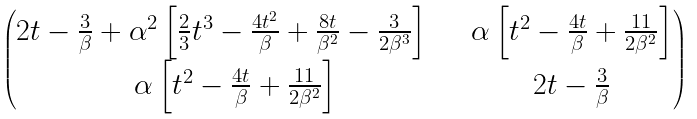Convert formula to latex. <formula><loc_0><loc_0><loc_500><loc_500>\begin{pmatrix} 2 t - \frac { 3 } { \beta } + \alpha ^ { 2 } \left [ \frac { 2 } { 3 } t ^ { 3 } - \frac { 4 t ^ { 2 } } { \beta } + \frac { 8 t } { \beta ^ { 2 } } - \frac { 3 } { 2 \beta ^ { 3 } } \right ] \quad & \alpha \left [ t ^ { 2 } - \frac { 4 t } { \beta } + \frac { 1 1 } { 2 \beta ^ { 2 } } \right ] \\ \alpha \left [ t ^ { 2 } - \frac { 4 t } { \beta } + \frac { 1 1 } { 2 \beta ^ { 2 } } \right ] & 2 t - \frac { 3 } { \beta } \end{pmatrix}</formula> 